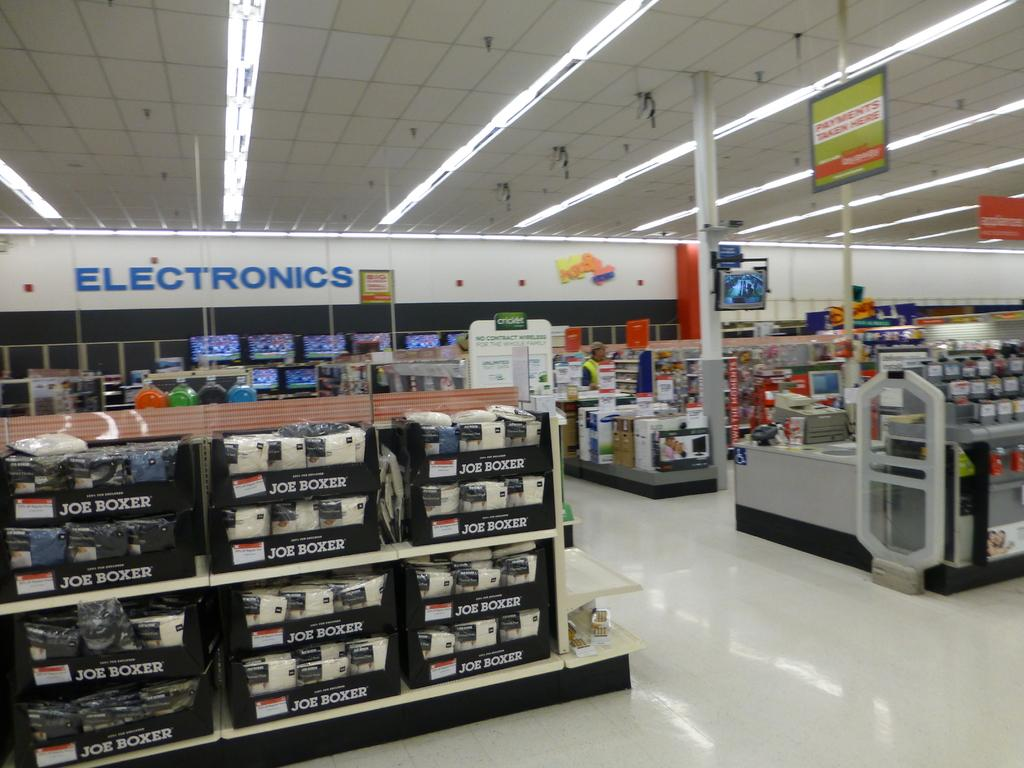<image>
Relay a brief, clear account of the picture shown. A sign over the Electronics section of the store is written in blue. 